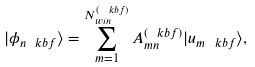<formula> <loc_0><loc_0><loc_500><loc_500>| \phi _ { n \ k b f } \rangle = \sum _ { m = 1 } ^ { N ^ { ( \ k b f ) } _ { w i n } } A _ { m n } ^ { ( \ k b f ) } | u _ { m \ k b f } \rangle ,</formula> 